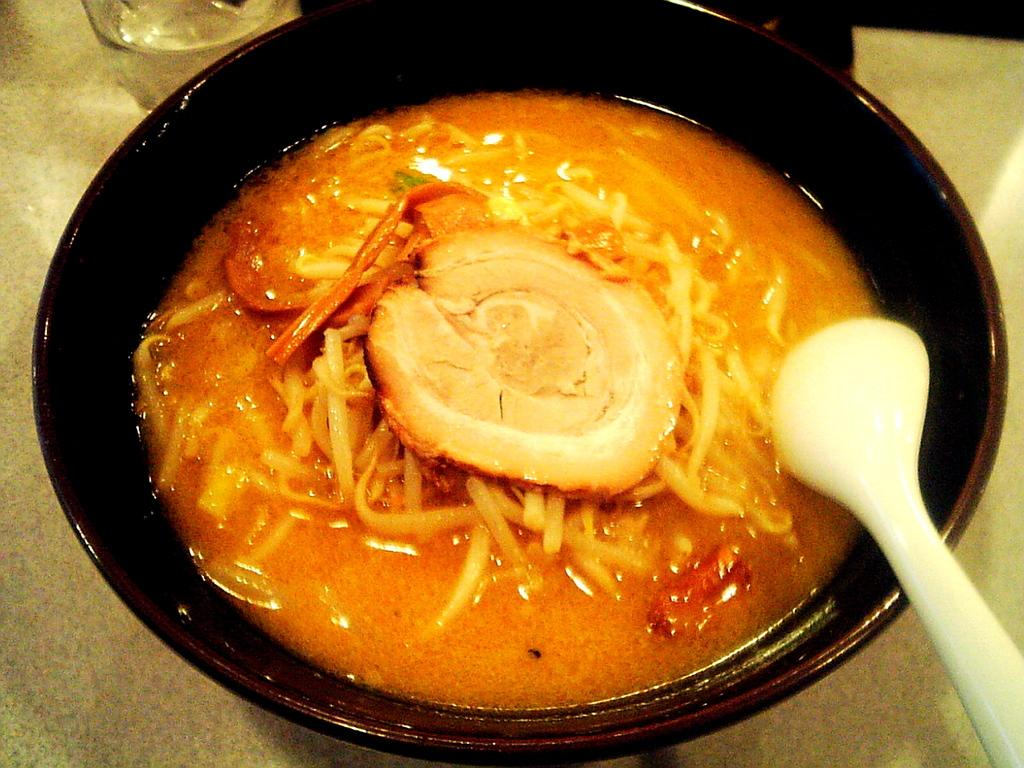What is the color of the bowl in the image? The bowl is black in color. What is inside the bowl? There is a food item in the bowl. What utensil is present in the image? There is a spoon in the image. What is the color of the spoon? The spoon is white in color. What other object can be seen in the image? There is a glass in the image. Can you see any straws in the image? There are no straws present in the image. Is there a window visible in the image? There is no window visible in the image. 